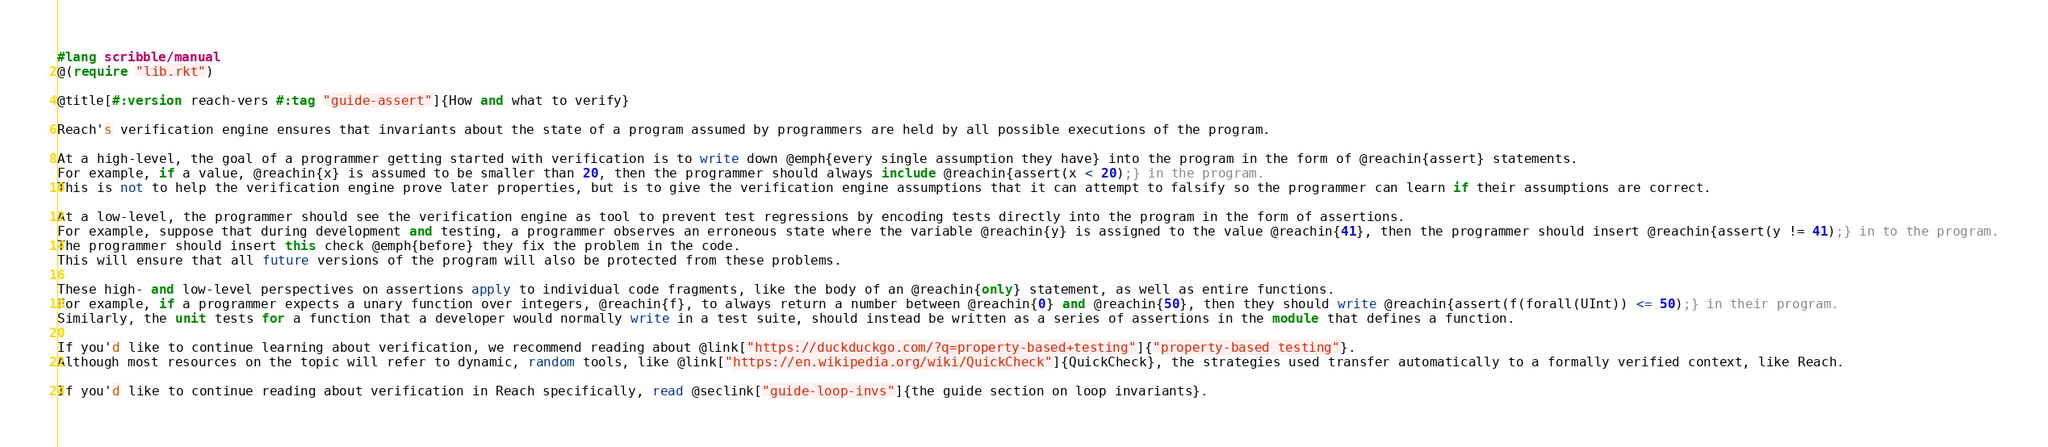Convert code to text. <code><loc_0><loc_0><loc_500><loc_500><_Racket_>#lang scribble/manual
@(require "lib.rkt")

@title[#:version reach-vers #:tag "guide-assert"]{How and what to verify}

Reach's verification engine ensures that invariants about the state of a program assumed by programmers are held by all possible executions of the program.

At a high-level, the goal of a programmer getting started with verification is to write down @emph{every single assumption they have} into the program in the form of @reachin{assert} statements.
For example, if a value, @reachin{x} is assumed to be smaller than 20, then the programmer should always include @reachin{assert(x < 20);} in the program.
This is not to help the verification engine prove later properties, but is to give the verification engine assumptions that it can attempt to falsify so the programmer can learn if their assumptions are correct.

At a low-level, the programmer should see the verification engine as tool to prevent test regressions by encoding tests directly into the program in the form of assertions.
For example, suppose that during development and testing, a programmer observes an erroneous state where the variable @reachin{y} is assigned to the value @reachin{41}, then the programmer should insert @reachin{assert(y != 41);} in to the program.
The programmer should insert this check @emph{before} they fix the problem in the code.
This will ensure that all future versions of the program will also be protected from these problems.

These high- and low-level perspectives on assertions apply to individual code fragments, like the body of an @reachin{only} statement, as well as entire functions.
For example, if a programmer expects a unary function over integers, @reachin{f}, to always return a number between @reachin{0} and @reachin{50}, then they should write @reachin{assert(f(forall(UInt)) <= 50);} in their program.
Similarly, the unit tests for a function that a developer would normally write in a test suite, should instead be written as a series of assertions in the module that defines a function.

If you'd like to continue learning about verification, we recommend reading about @link["https://duckduckgo.com/?q=property-based+testing"]{"property-based testing"}.
Although most resources on the topic will refer to dynamic, random tools, like @link["https://en.wikipedia.org/wiki/QuickCheck"]{QuickCheck}, the strategies used transfer automatically to a formally verified context, like Reach.

If you'd like to continue reading about verification in Reach specifically, read @seclink["guide-loop-invs"]{the guide section on loop invariants}.
</code> 